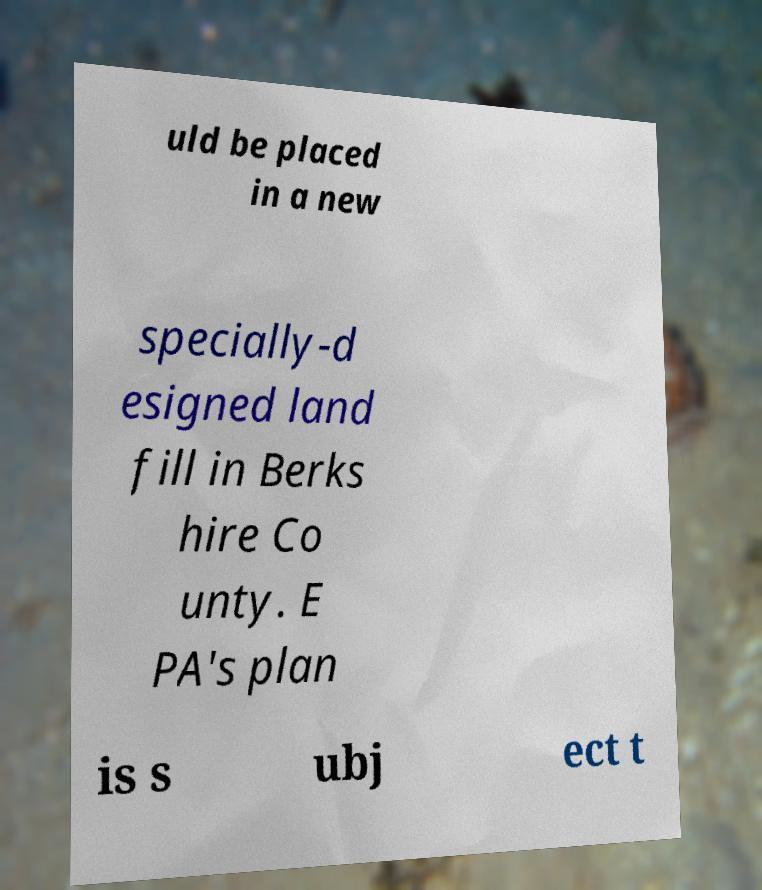Could you extract and type out the text from this image? uld be placed in a new specially-d esigned land fill in Berks hire Co unty. E PA's plan is s ubj ect t 